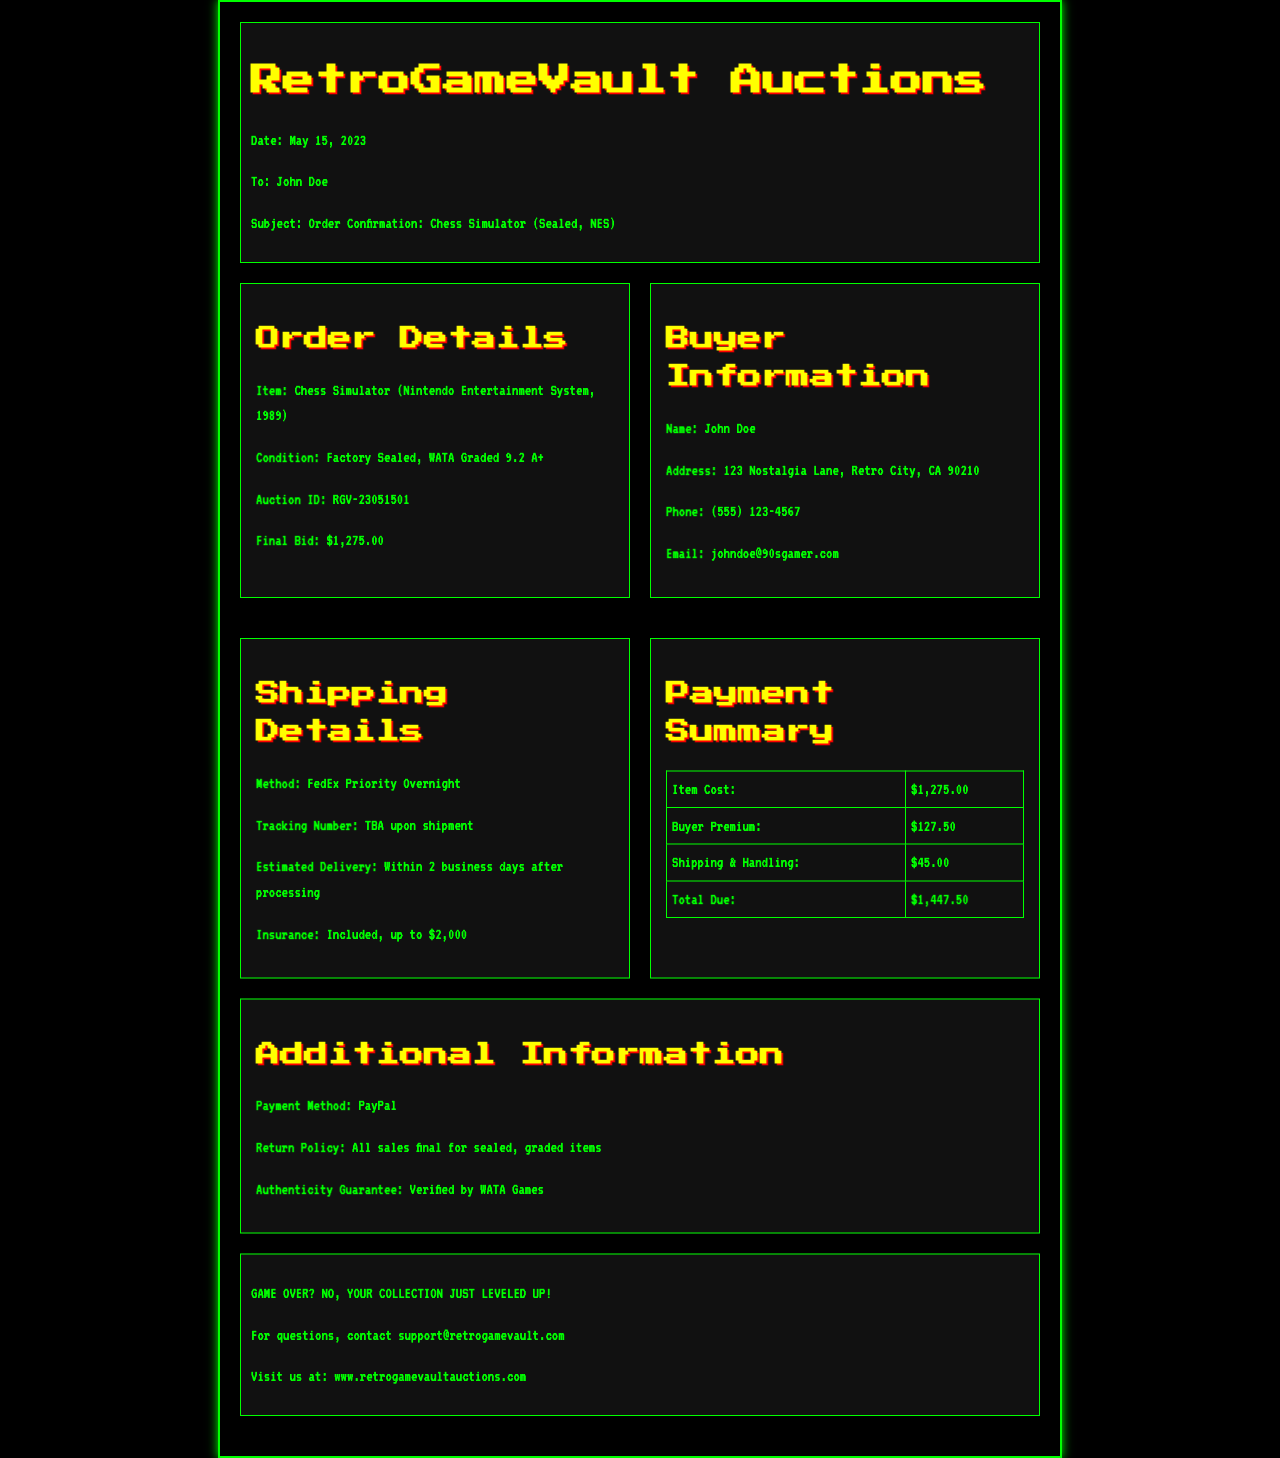what is the item being ordered? The document states the item as "Chess Simulator (Nintendo Entertainment System, 1989)", which is the specific game being purchased.
Answer: Chess Simulator (Nintendo Entertainment System, 1989) who is the buyer? The buyer is identified as "John Doe" in the document, which provides the name of the individual making the purchase.
Answer: John Doe what is the final bid amount? The final bid for the item is clearly listed in the document as $1,275.00, which indicates the price paid at auction.
Answer: $1,275.00 what is the shipping method? The document specifies that the shipping method is "FedEx Priority Overnight," indicating the courier service selected for delivery.
Answer: FedEx Priority Overnight when was the order confirmed? The date of the order confirmation is stated as May 15, 2023, which is essential for tracking the order timeline.
Answer: May 15, 2023 how much is the total due? The total amount due is calculated in the payment summary section, which includes all costs associated with the order.
Answer: $1,447.50 what is the estimated delivery time? The document mentions the estimated delivery as "Within 2 business days after processing," which sets expectations for how soon the buyer will receive the item.
Answer: Within 2 business days after processing is there a guarantee of authenticity? The document asserts that there is an "Authenticity Guarantee," which confirms that the item has been verified for its legitimacy.
Answer: Verified by WATA Games what is the payment method used? The payment method is indicated in the additional information section of the document, specifying how the transaction was completed.
Answer: PayPal 